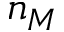<formula> <loc_0><loc_0><loc_500><loc_500>n _ { M }</formula> 